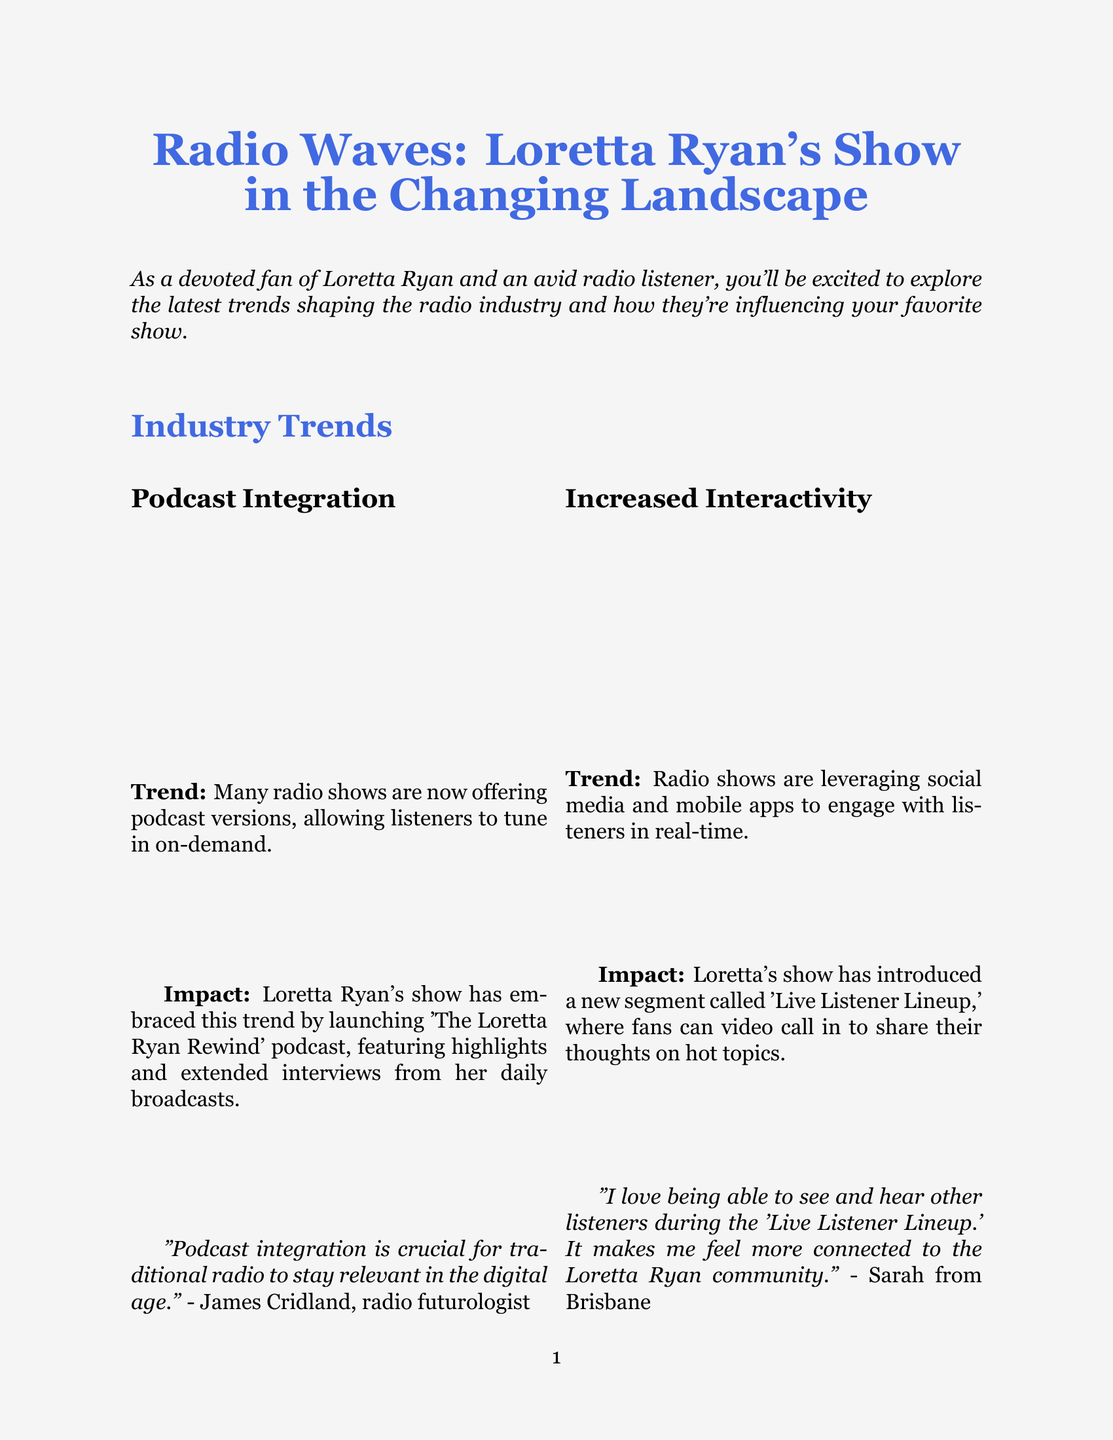What is the title of the newsletter? The title is located at the beginning of the document and summarizes the content focus.
Answer: Radio Waves: Loretta Ryan's Show in the Changing Landscape Who is the radio futurologist mentioned in the document? The expert opinion provided in the document attributes a quote to a specific individual.
Answer: James Cridland What percentage of listeners appreciate the podcast offering? This information is included in the listener survey findings section of the document.
Answer: 92% What new segment has Loretta's show introduced? The impact of radio trends on Loretta's show includes the introduction of a specific segment.
Answer: Live Listener Lineup How many participants were in the listener survey? The participant count is summarized in the section discussing the listener survey findings.
Answer: 5000 What expert opinion is shared about hyper-local content? The document includes a specific statement made by an expert regarding the importance of a particular trend.
Answer: Hyper-local content is a key differentiator for radio in the streaming era What upcoming change involves collaboration with local artists? The document outlines future developments for Loretta's show that include potential collaborative efforts.
Answer: Collaboration with local artists for live in-studio performances What is the new podcast launched by Loretta Ryan's show called? The impact of podcast integration on the show is linked to the name of the new podcast.
Answer: The Loretta Ryan Rewind 